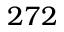<formula> <loc_0><loc_0><loc_500><loc_500>2 7 2</formula> 